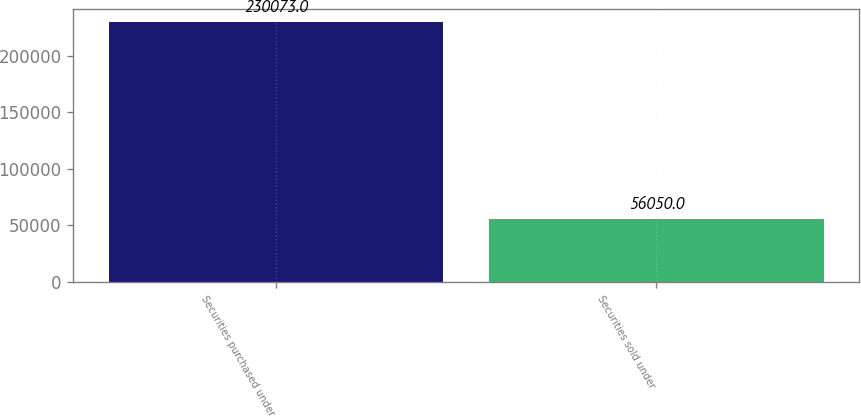Convert chart. <chart><loc_0><loc_0><loc_500><loc_500><bar_chart><fcel>Securities purchased under<fcel>Securities sold under<nl><fcel>230073<fcel>56050<nl></chart> 